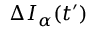<formula> <loc_0><loc_0><loc_500><loc_500>\Delta I _ { \alpha } ( t ^ { \prime } )</formula> 